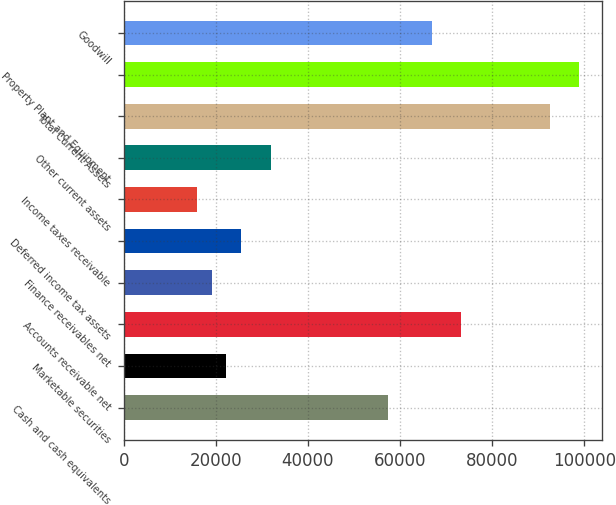Convert chart. <chart><loc_0><loc_0><loc_500><loc_500><bar_chart><fcel>Cash and cash equivalents<fcel>Marketable securities<fcel>Accounts receivable net<fcel>Finance receivables net<fcel>Deferred income tax assets<fcel>Income taxes receivable<fcel>Other current assets<fcel>Total Current Assets<fcel>Property Plant and Equipment<fcel>Goodwill<nl><fcel>57387<fcel>22319<fcel>73327<fcel>19131<fcel>25507<fcel>15943<fcel>31883<fcel>92455<fcel>98831<fcel>66951<nl></chart> 